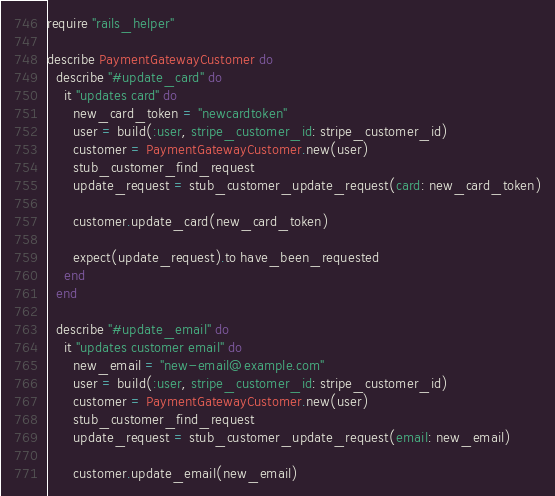<code> <loc_0><loc_0><loc_500><loc_500><_Ruby_>require "rails_helper"

describe PaymentGatewayCustomer do
  describe "#update_card" do
    it "updates card" do
      new_card_token = "newcardtoken"
      user = build(:user, stripe_customer_id: stripe_customer_id)
      customer = PaymentGatewayCustomer.new(user)
      stub_customer_find_request
      update_request = stub_customer_update_request(card: new_card_token)

      customer.update_card(new_card_token)

      expect(update_request).to have_been_requested
    end
  end

  describe "#update_email" do
    it "updates customer email" do
      new_email = "new-email@example.com"
      user = build(:user, stripe_customer_id: stripe_customer_id)
      customer = PaymentGatewayCustomer.new(user)
      stub_customer_find_request
      update_request = stub_customer_update_request(email: new_email)

      customer.update_email(new_email)
</code> 